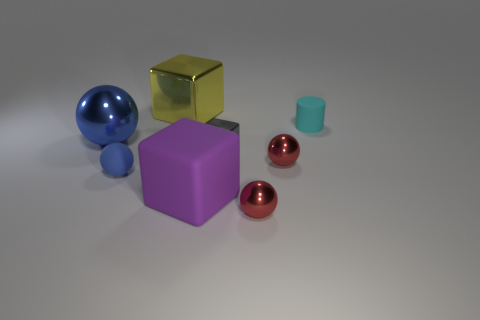Subtract all small shiny blocks. How many blocks are left? 2 Subtract 1 spheres. How many spheres are left? 3 Add 1 large yellow shiny objects. How many objects exist? 9 Subtract all cyan cubes. Subtract all gray cylinders. How many cubes are left? 3 Subtract all blue blocks. Subtract all red metal balls. How many objects are left? 6 Add 6 big blocks. How many big blocks are left? 8 Add 5 gray shiny cubes. How many gray shiny cubes exist? 6 Subtract 1 cyan cylinders. How many objects are left? 7 Subtract all blocks. How many objects are left? 5 